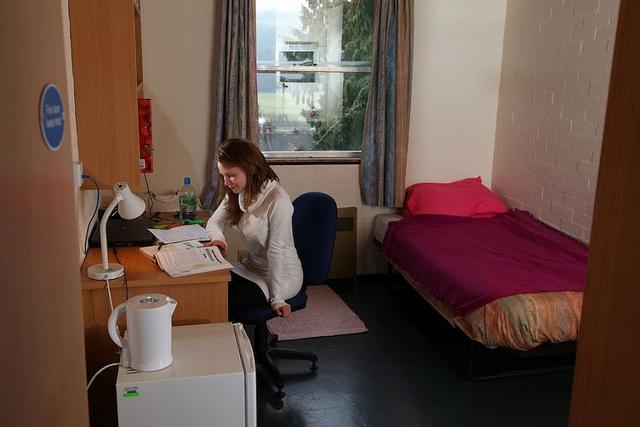What is next to the bed?
Be succinct. Window. What color is her pillow?
Be succinct. Pink. What type of scene is it?
Short answer required. Bedroom. Does the girl have a roommate?
Concise answer only. No. 